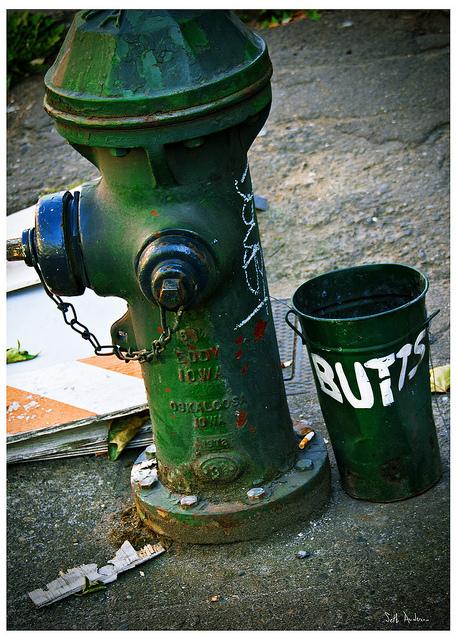What color is the hydrant?
Answer briefly. Green. Have all the cigarette butts been deposited in the appropriate receptacle?
Keep it brief. No. What does the can read?
Write a very short answer. Butts. 